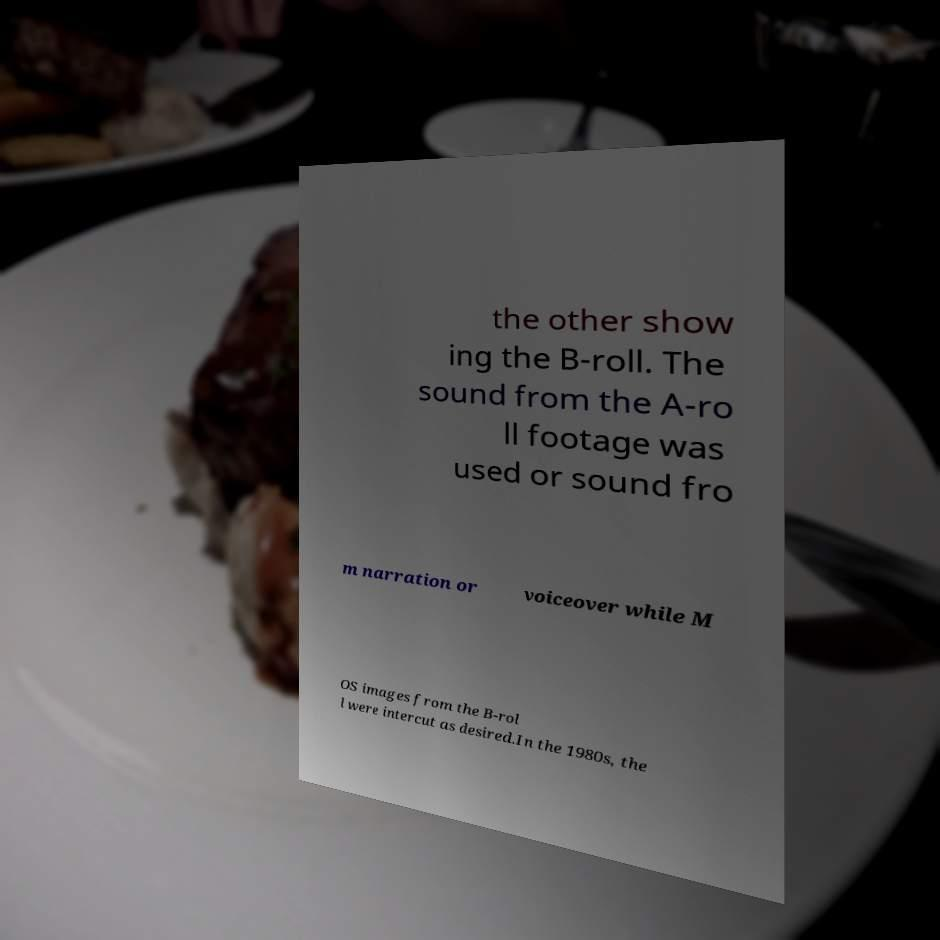Could you extract and type out the text from this image? the other show ing the B-roll. The sound from the A-ro ll footage was used or sound fro m narration or voiceover while M OS images from the B-rol l were intercut as desired.In the 1980s, the 